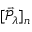<formula> <loc_0><loc_0><loc_500><loc_500>[ \vec { \mathcal { P } } _ { \lambda } ] _ { n }</formula> 